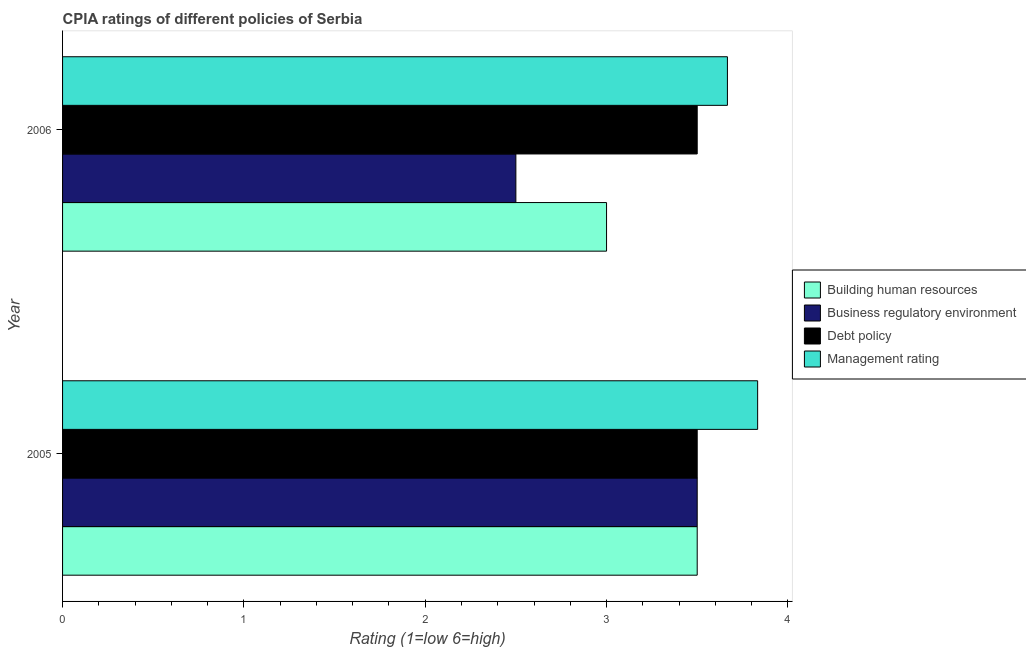How many different coloured bars are there?
Keep it short and to the point. 4. How many groups of bars are there?
Offer a terse response. 2. Are the number of bars per tick equal to the number of legend labels?
Your answer should be very brief. Yes. Are the number of bars on each tick of the Y-axis equal?
Make the answer very short. Yes. How many bars are there on the 1st tick from the top?
Give a very brief answer. 4. How many bars are there on the 2nd tick from the bottom?
Keep it short and to the point. 4. In how many cases, is the number of bars for a given year not equal to the number of legend labels?
Your answer should be compact. 0. Across all years, what is the maximum cpia rating of debt policy?
Your response must be concise. 3.5. Across all years, what is the minimum cpia rating of management?
Keep it short and to the point. 3.67. In which year was the cpia rating of debt policy maximum?
Make the answer very short. 2005. In which year was the cpia rating of business regulatory environment minimum?
Provide a succinct answer. 2006. What is the total cpia rating of management in the graph?
Offer a very short reply. 7.5. What is the difference between the cpia rating of management in 2005 and that in 2006?
Your answer should be compact. 0.17. What is the difference between the cpia rating of building human resources in 2006 and the cpia rating of business regulatory environment in 2005?
Your answer should be very brief. -0.5. What is the average cpia rating of debt policy per year?
Offer a terse response. 3.5. In the year 2006, what is the difference between the cpia rating of business regulatory environment and cpia rating of debt policy?
Make the answer very short. -1. What is the ratio of the cpia rating of debt policy in 2005 to that in 2006?
Make the answer very short. 1. Is the cpia rating of management in 2005 less than that in 2006?
Ensure brevity in your answer.  No. Is the difference between the cpia rating of debt policy in 2005 and 2006 greater than the difference between the cpia rating of building human resources in 2005 and 2006?
Make the answer very short. No. In how many years, is the cpia rating of management greater than the average cpia rating of management taken over all years?
Give a very brief answer. 1. What does the 1st bar from the top in 2005 represents?
Offer a very short reply. Management rating. What does the 1st bar from the bottom in 2006 represents?
Provide a succinct answer. Building human resources. Is it the case that in every year, the sum of the cpia rating of building human resources and cpia rating of business regulatory environment is greater than the cpia rating of debt policy?
Ensure brevity in your answer.  Yes. How many bars are there?
Provide a short and direct response. 8. How many years are there in the graph?
Provide a succinct answer. 2. Does the graph contain grids?
Offer a very short reply. No. Where does the legend appear in the graph?
Offer a very short reply. Center right. How are the legend labels stacked?
Provide a succinct answer. Vertical. What is the title of the graph?
Your answer should be very brief. CPIA ratings of different policies of Serbia. Does "Manufacturing" appear as one of the legend labels in the graph?
Provide a succinct answer. No. What is the Rating (1=low 6=high) of Business regulatory environment in 2005?
Offer a very short reply. 3.5. What is the Rating (1=low 6=high) in Debt policy in 2005?
Provide a succinct answer. 3.5. What is the Rating (1=low 6=high) of Management rating in 2005?
Keep it short and to the point. 3.83. What is the Rating (1=low 6=high) of Building human resources in 2006?
Provide a short and direct response. 3. What is the Rating (1=low 6=high) of Business regulatory environment in 2006?
Give a very brief answer. 2.5. What is the Rating (1=low 6=high) in Debt policy in 2006?
Offer a very short reply. 3.5. What is the Rating (1=low 6=high) of Management rating in 2006?
Your response must be concise. 3.67. Across all years, what is the maximum Rating (1=low 6=high) in Building human resources?
Your answer should be compact. 3.5. Across all years, what is the maximum Rating (1=low 6=high) in Management rating?
Give a very brief answer. 3.83. Across all years, what is the minimum Rating (1=low 6=high) of Building human resources?
Offer a very short reply. 3. Across all years, what is the minimum Rating (1=low 6=high) in Debt policy?
Ensure brevity in your answer.  3.5. Across all years, what is the minimum Rating (1=low 6=high) in Management rating?
Ensure brevity in your answer.  3.67. What is the total Rating (1=low 6=high) in Business regulatory environment in the graph?
Offer a terse response. 6. What is the total Rating (1=low 6=high) in Debt policy in the graph?
Offer a very short reply. 7. What is the total Rating (1=low 6=high) of Management rating in the graph?
Provide a short and direct response. 7.5. What is the difference between the Rating (1=low 6=high) of Building human resources in 2005 and that in 2006?
Provide a succinct answer. 0.5. What is the difference between the Rating (1=low 6=high) in Business regulatory environment in 2005 and that in 2006?
Make the answer very short. 1. What is the difference between the Rating (1=low 6=high) in Management rating in 2005 and that in 2006?
Your answer should be compact. 0.17. What is the difference between the Rating (1=low 6=high) of Building human resources in 2005 and the Rating (1=low 6=high) of Management rating in 2006?
Give a very brief answer. -0.17. What is the difference between the Rating (1=low 6=high) in Business regulatory environment in 2005 and the Rating (1=low 6=high) in Debt policy in 2006?
Your answer should be compact. 0. What is the difference between the Rating (1=low 6=high) of Debt policy in 2005 and the Rating (1=low 6=high) of Management rating in 2006?
Your answer should be compact. -0.17. What is the average Rating (1=low 6=high) of Building human resources per year?
Your answer should be compact. 3.25. What is the average Rating (1=low 6=high) in Business regulatory environment per year?
Give a very brief answer. 3. What is the average Rating (1=low 6=high) in Debt policy per year?
Provide a succinct answer. 3.5. What is the average Rating (1=low 6=high) in Management rating per year?
Your answer should be very brief. 3.75. In the year 2005, what is the difference between the Rating (1=low 6=high) of Building human resources and Rating (1=low 6=high) of Debt policy?
Ensure brevity in your answer.  0. In the year 2005, what is the difference between the Rating (1=low 6=high) of Business regulatory environment and Rating (1=low 6=high) of Management rating?
Your answer should be very brief. -0.33. In the year 2005, what is the difference between the Rating (1=low 6=high) in Debt policy and Rating (1=low 6=high) in Management rating?
Ensure brevity in your answer.  -0.33. In the year 2006, what is the difference between the Rating (1=low 6=high) in Building human resources and Rating (1=low 6=high) in Debt policy?
Keep it short and to the point. -0.5. In the year 2006, what is the difference between the Rating (1=low 6=high) of Building human resources and Rating (1=low 6=high) of Management rating?
Make the answer very short. -0.67. In the year 2006, what is the difference between the Rating (1=low 6=high) of Business regulatory environment and Rating (1=low 6=high) of Management rating?
Ensure brevity in your answer.  -1.17. In the year 2006, what is the difference between the Rating (1=low 6=high) of Debt policy and Rating (1=low 6=high) of Management rating?
Your answer should be compact. -0.17. What is the ratio of the Rating (1=low 6=high) of Debt policy in 2005 to that in 2006?
Your answer should be very brief. 1. What is the ratio of the Rating (1=low 6=high) of Management rating in 2005 to that in 2006?
Your answer should be very brief. 1.05. What is the difference between the highest and the second highest Rating (1=low 6=high) in Building human resources?
Give a very brief answer. 0.5. What is the difference between the highest and the second highest Rating (1=low 6=high) in Debt policy?
Keep it short and to the point. 0. What is the difference between the highest and the second highest Rating (1=low 6=high) in Management rating?
Your answer should be very brief. 0.17. What is the difference between the highest and the lowest Rating (1=low 6=high) in Building human resources?
Your answer should be very brief. 0.5. What is the difference between the highest and the lowest Rating (1=low 6=high) of Debt policy?
Keep it short and to the point. 0. 